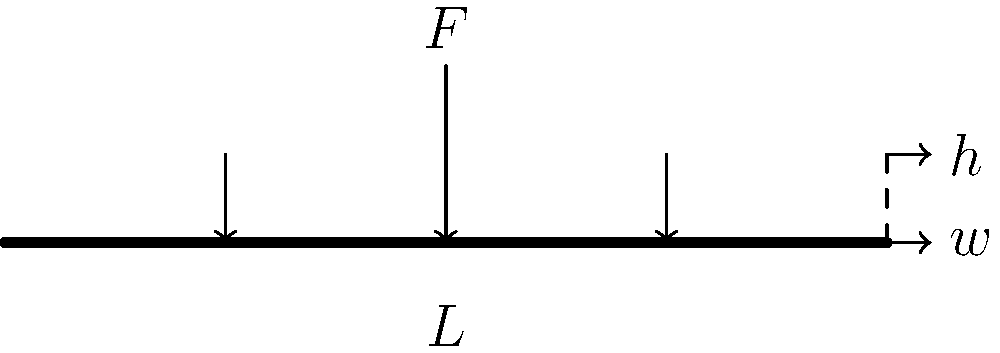As a restoration expert, you're analyzing a structural beam in a historic building. The beam has a rectangular cross-section with width $w = 0.15$ m and height $h = 0.3$ m. It spans a length $L = 5$ m and is subjected to a central point load $F = 50$ kN. Calculate the maximum normal stress and the maximum strain in the beam, given that the beam is made of oak with a Young's modulus $E = 11$ GPa. Let's approach this step-by-step:

1) First, we need to calculate the moment of inertia (I) for the rectangular cross-section:
   $I = \frac{1}{12}wh^3 = \frac{1}{12} \cdot 0.15 \cdot 0.3^3 = 3.375 \times 10^{-4}$ m⁴

2) The maximum bending moment (M) occurs at the center of the beam and is given by:
   $M = \frac{FL}{4} = \frac{50,000 \cdot 5}{4} = 62,500$ N·m

3) The maximum normal stress (σ) occurs at the outer fibers of the beam and is calculated using the flexure formula:
   $\sigma = \frac{My}{I}$, where $y = h/2 = 0.15$ m
   $\sigma = \frac{62,500 \cdot 0.15}{3.375 \times 10^{-4}} = 27.78$ MPa

4) The maximum strain (ε) can be calculated using Hooke's law:
   $\varepsilon = \frac{\sigma}{E} = \frac{27.78 \times 10^6}{11 \times 10^9} = 2.525 \times 10^{-3}$

Therefore, the maximum normal stress is 27.78 MPa and the maximum strain is 2.525 × 10⁻³.
Answer: $\sigma_{max} = 27.78$ MPa, $\varepsilon_{max} = 2.525 \times 10^{-3}$ 